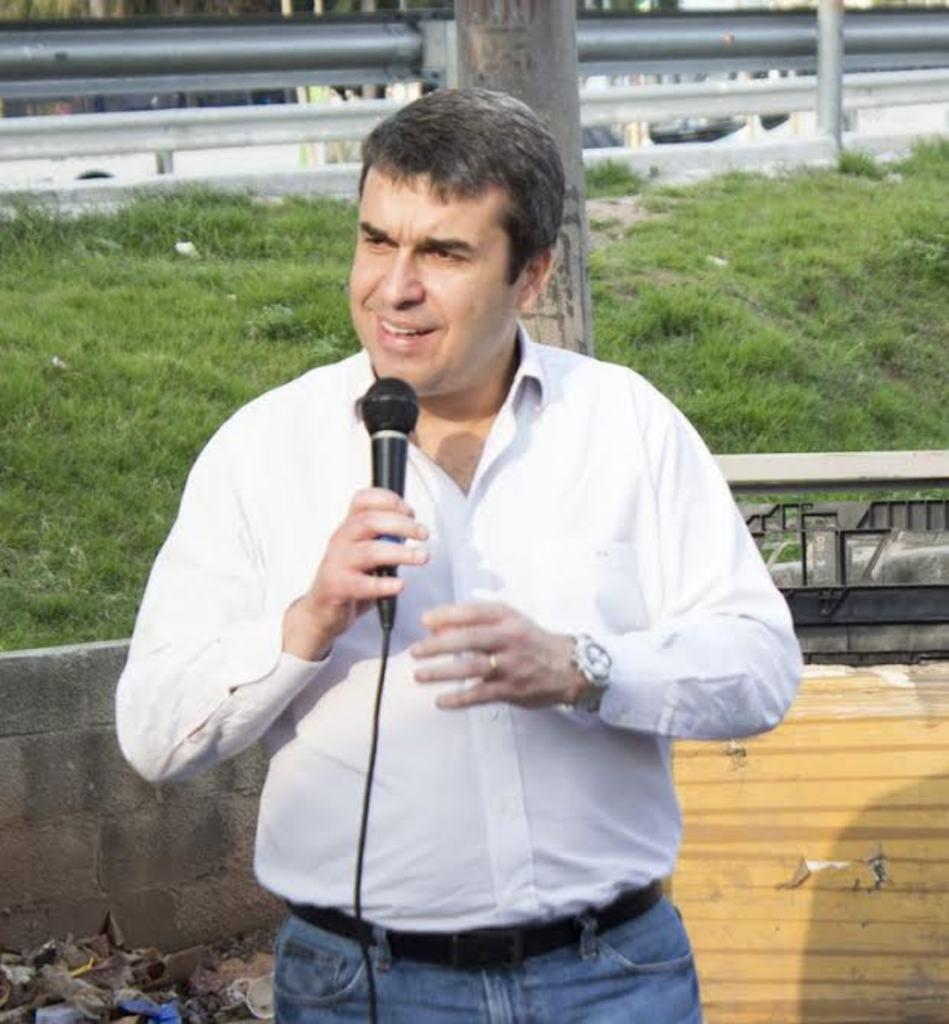What is the man in the center of the image doing? The man is standing in the center of the image and holding a mic. What can be seen in the background of the image? There is grass, a pole, rods, vehicles, a wall, and some garbage visible in the background of the image. What type of birthday celebration is taking place in the image? There is no indication of a birthday celebration in the image. What is on top of the wall in the image? The provided facts do not mention anything being on top of the wall in the image. 